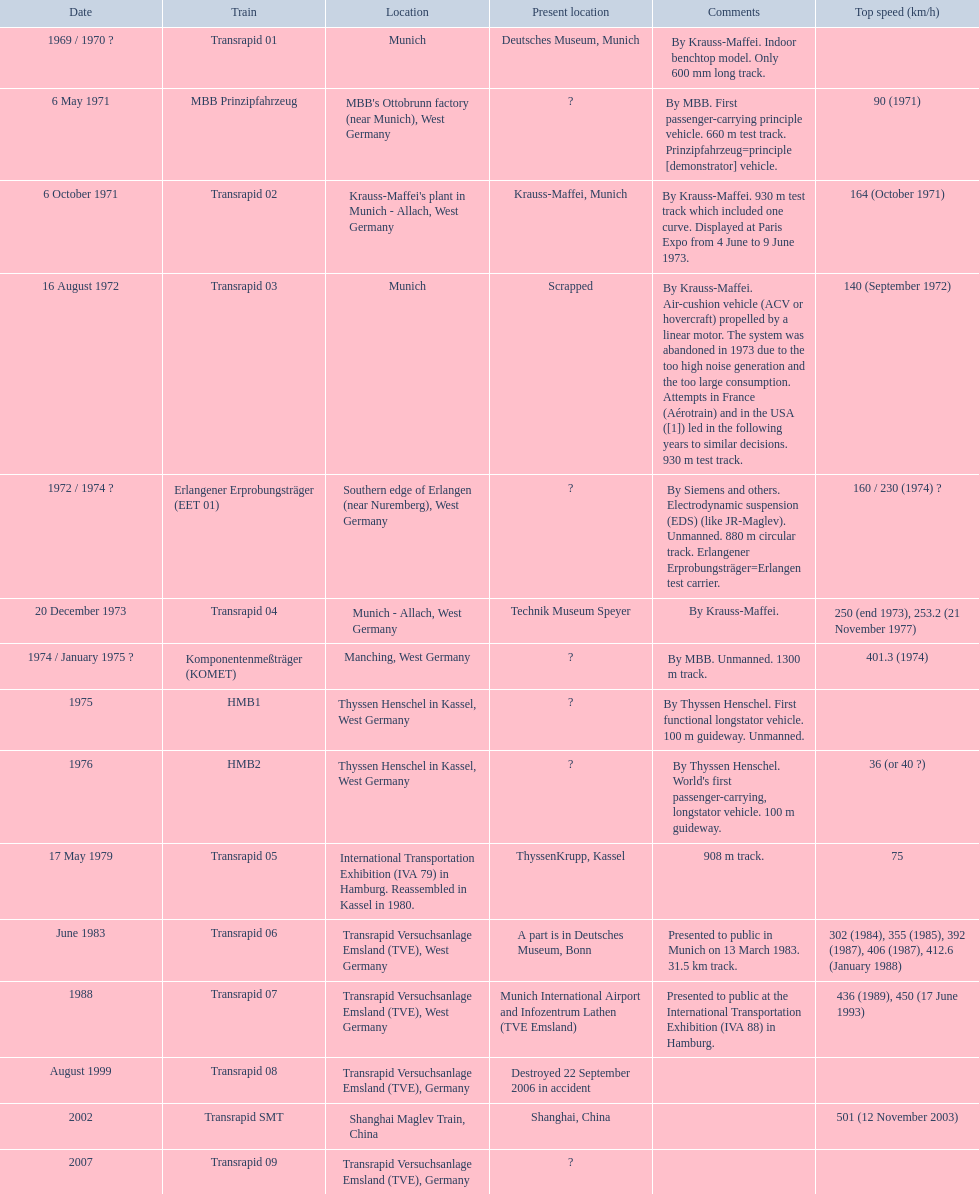Which trains had a highest speed recorded? MBB Prinzipfahrzeug, Transrapid 02, Transrapid 03, Erlangener Erprobungsträger (EET 01), Transrapid 04, Komponentenmeßträger (KOMET), HMB2, Transrapid 05, Transrapid 06, Transrapid 07, Transrapid SMT. Which ones have munich as a location? MBB Prinzipfahrzeug, Transrapid 02, Transrapid 03. From these, which ones have an identifiable present location? Transrapid 02, Transrapid 03. Which of those is discontinued? Transrapid 03. 